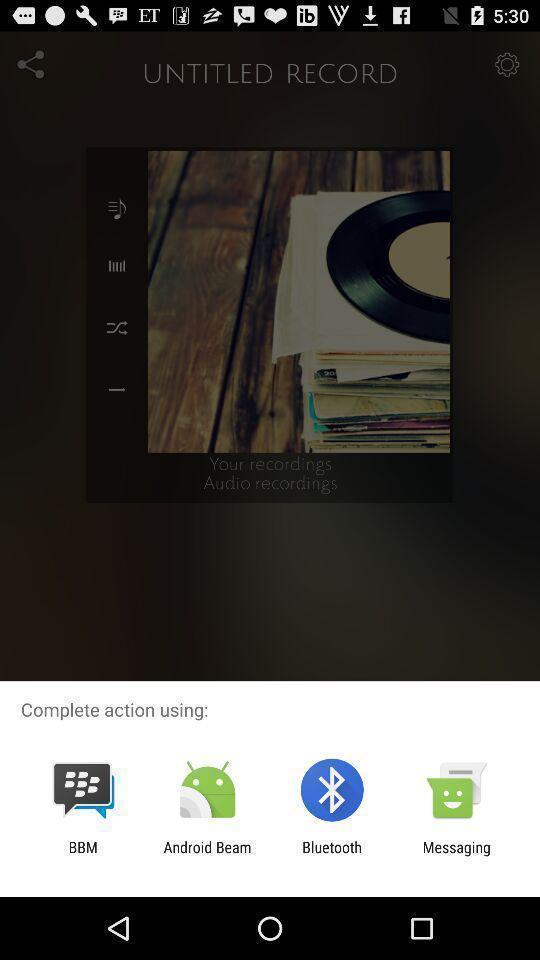Please provide a description for this image. Pop-up showing about using through apps. 